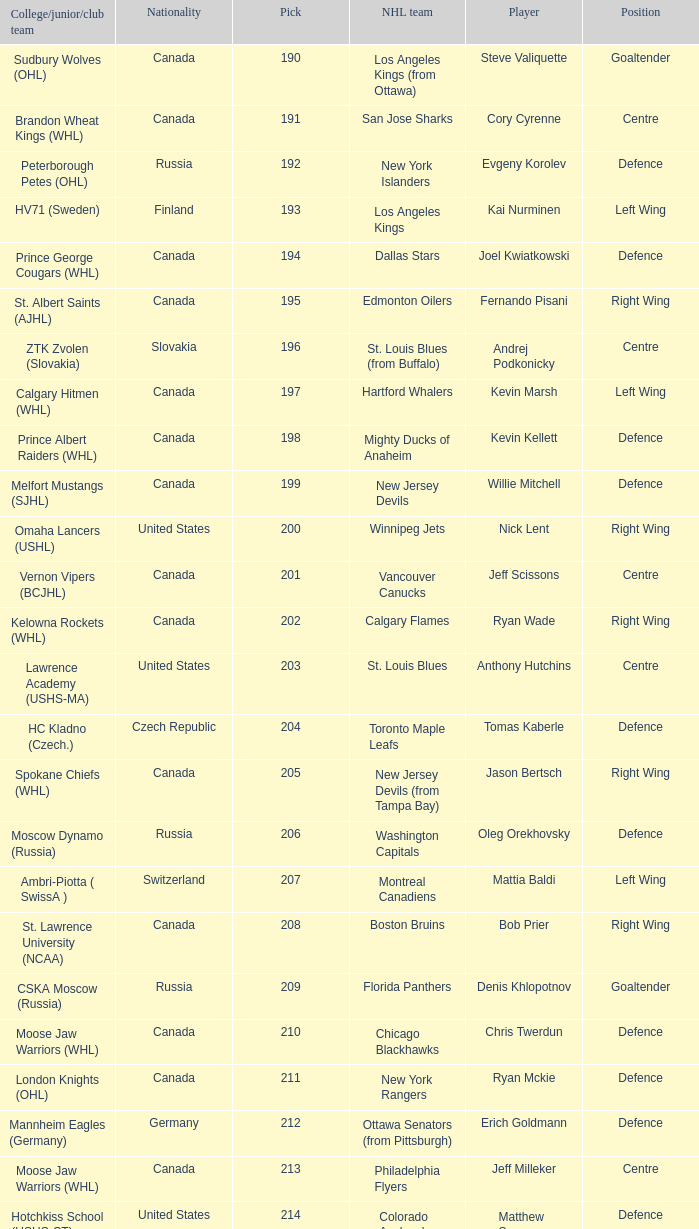Name the college for andrej podkonicky ZTK Zvolen (Slovakia). 